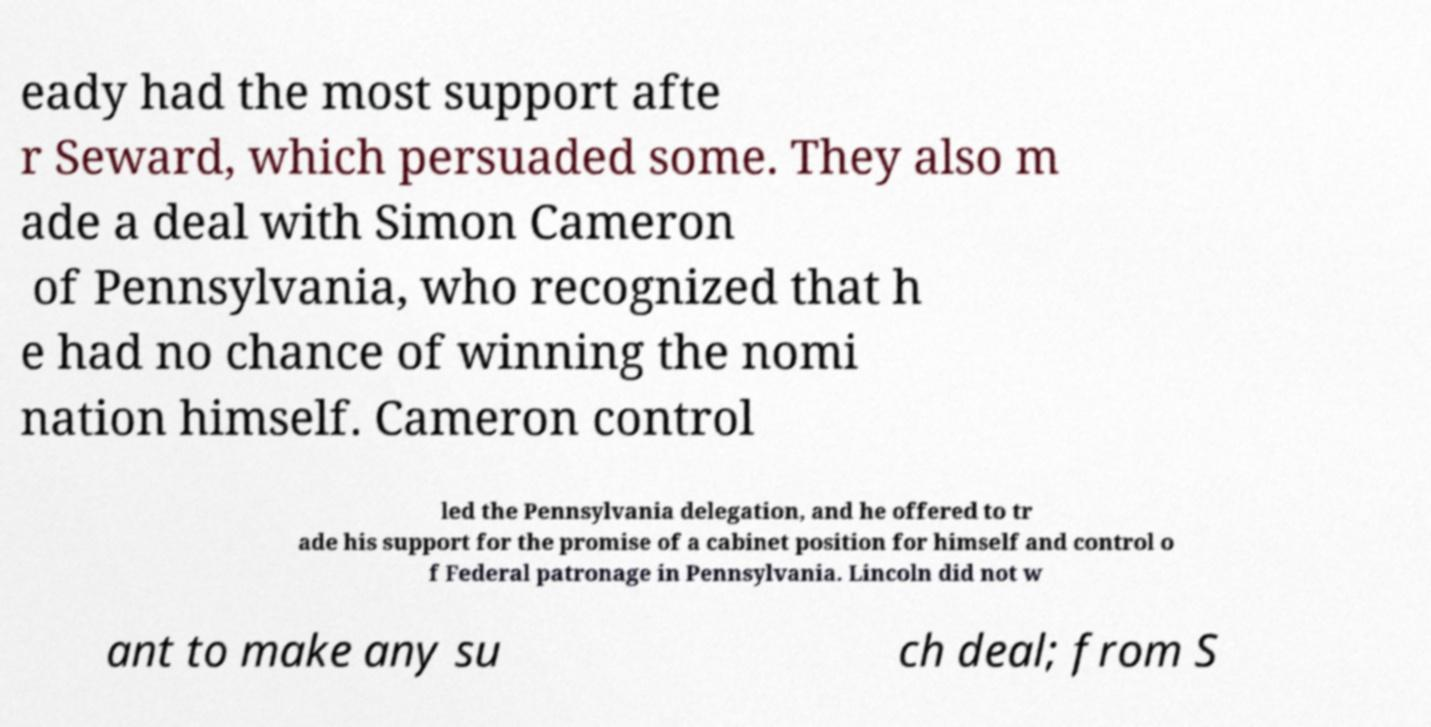Can you read and provide the text displayed in the image?This photo seems to have some interesting text. Can you extract and type it out for me? eady had the most support afte r Seward, which persuaded some. They also m ade a deal with Simon Cameron of Pennsylvania, who recognized that h e had no chance of winning the nomi nation himself. Cameron control led the Pennsylvania delegation, and he offered to tr ade his support for the promise of a cabinet position for himself and control o f Federal patronage in Pennsylvania. Lincoln did not w ant to make any su ch deal; from S 